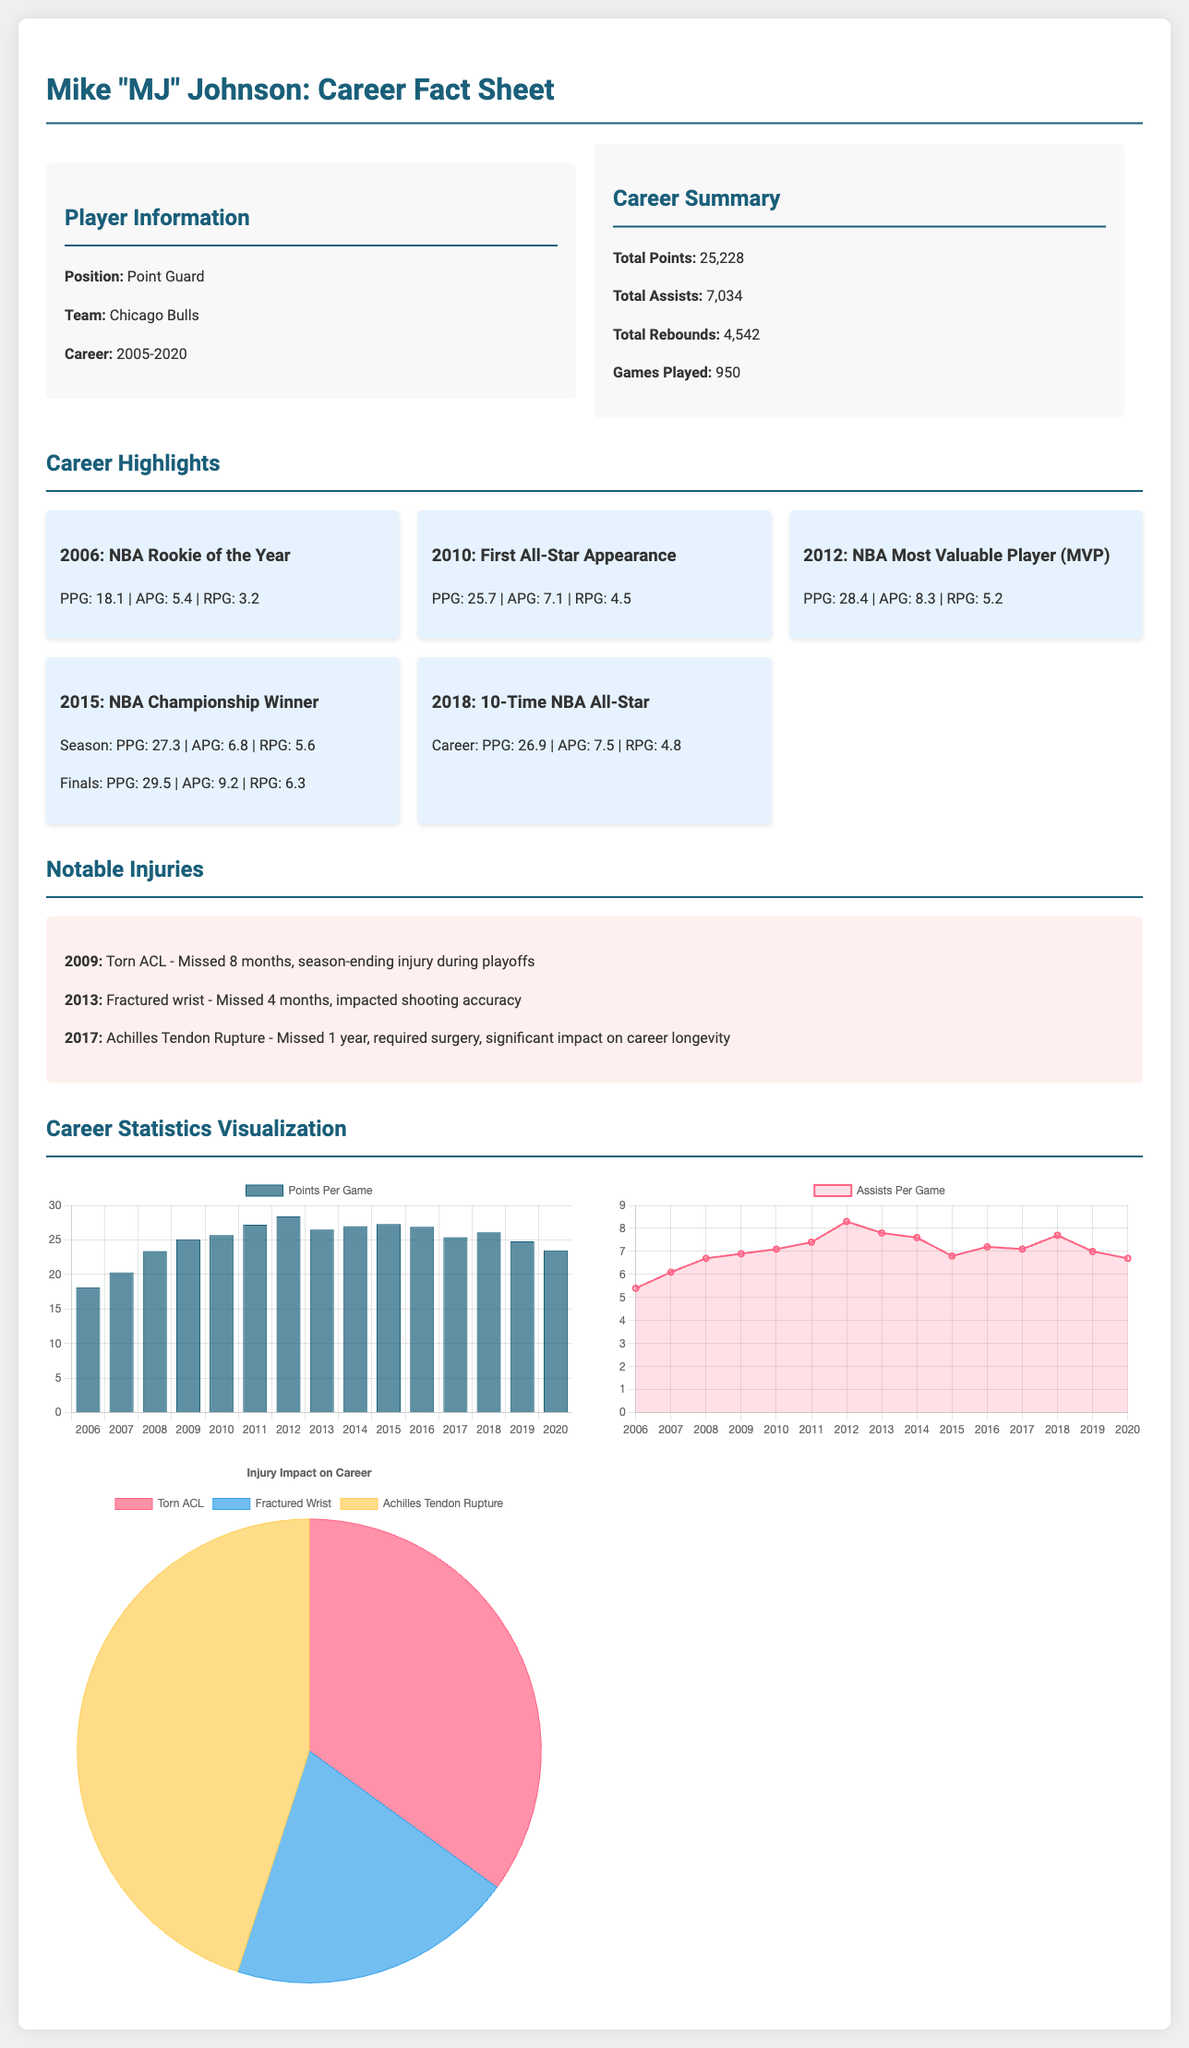What is Mike Johnson's total career points? The total career points are explicitly provided in the summary section of the document.
Answer: 25,228 Which injury did Mike Johnson sustain in 2009? The document lists notable injuries including the year and nature of the injuries.
Answer: Torn ACL What year did Mike Johnson become NBA MVP? The specific career highlights section mentions this achievement along with the year.
Answer: 2012 How many total assists did Mike Johnson have? The total assists are presented in the career summary section of the document.
Answer: 7,034 What was Mike Johnson's average points per game in 2015? The highlight card for 2015 shows the specific PPG for that year.
Answer: 27.3 How many times was Mike Johnson an NBA All-Star? The document specifies this achievement in one of the highlight cards, summarizing it as a count.
Answer: 10-Time What was the impact of the torn ACL injury on Mike Johnson's career? The document explains the context of the injury's impact, indicating it was a season-ending injury.
Answer: Missed 8 months In which year did Mike Johnson have his first All-Star appearance? The specific year is mentioned in the career highlights section along with the event.
Answer: 2010 What is the ratio of the injury impact (in months missed) for the Achilles tendon rupture compared to the fractured wrist? The months missed for each injury are mentioned, allowing for a ratio to be calculated from this information.
Answer: 3:2 